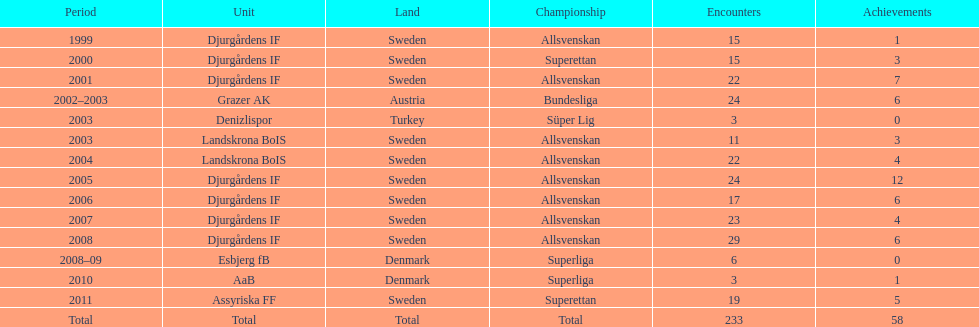How many total goals has jones kusi-asare scored? 58. 